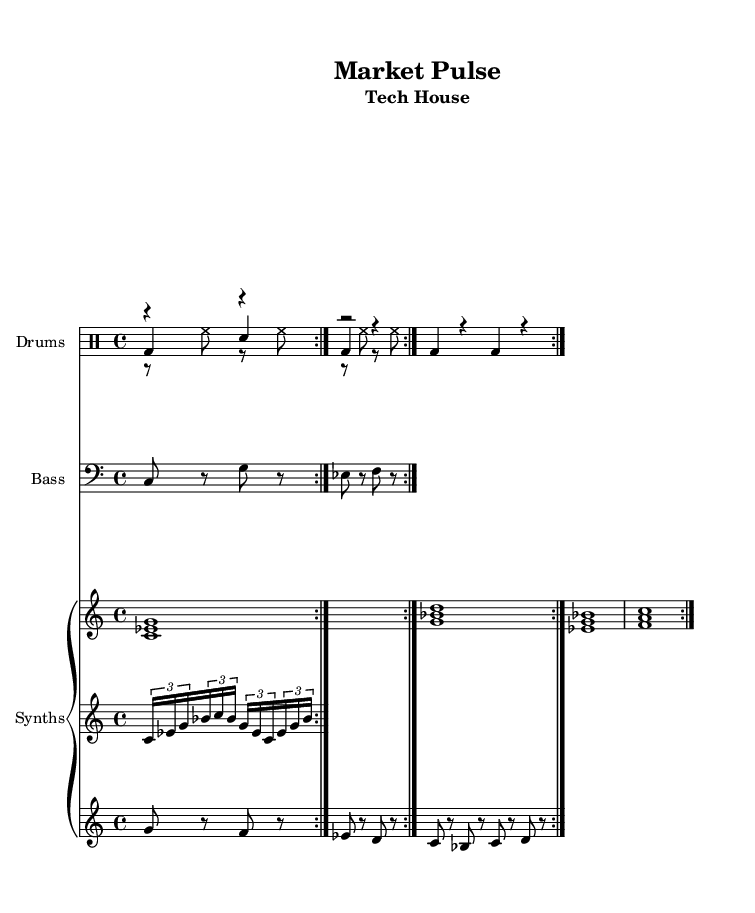What is the key signature of this music? The key signature of the piece is indicated at the beginning of the score, which shows C minor. C minor has three flats in its key signature.
Answer: C minor What is the time signature of this piece? The time signature is found near the beginning of the score and is marked as 4/4, meaning there are four beats in each measure.
Answer: 4/4 What is the tempo marking of the piece? The tempo marking indicates the speed of the music. In this score, it states "4 = 128," meaning there are 128 beats per minute.
Answer: 128 How many drum voices are used in the composition? By examining the drum staff in the score, there are three distinct drum voices: kick drum, hi-hat, and clap. Each is listed under its own voice.
Answer: Three What is the first note of the bassline? The bassline starts with a "C" note, which is the first note shown in the bass staff.
Answer: C What rhythmic pattern is used for the hi-hat? The hi-hat plays a consistent rhythm where it is primarily eighth notes, alternating with rests. It repeats a specific pattern two times as indicated in the notation.
Answer: Eighth notes How is the lead synth section structured? The lead synth section is structured with a combination of rests and notes in a varying pattern. It consists of eight notes plus rests in groups that repeat over two measures.
Answer: Groups of notes with rests 